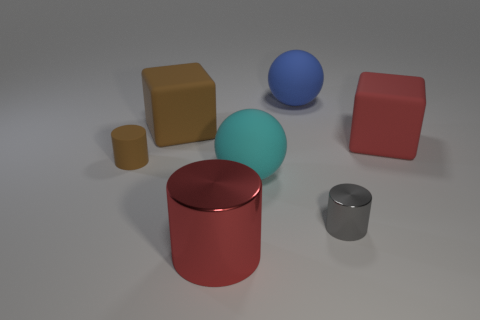Add 3 tiny gray metal spheres. How many objects exist? 10 Subtract all cylinders. How many objects are left? 4 Subtract 0 yellow spheres. How many objects are left? 7 Subtract all big cyan rubber objects. Subtract all big red cubes. How many objects are left? 5 Add 7 big blue balls. How many big blue balls are left? 8 Add 6 small blue metal things. How many small blue metal things exist? 6 